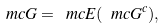<formula> <loc_0><loc_0><loc_500><loc_500>\ m c { G } = \ m c { E } ( { \ m c { G } ^ { c } } ) ,</formula> 